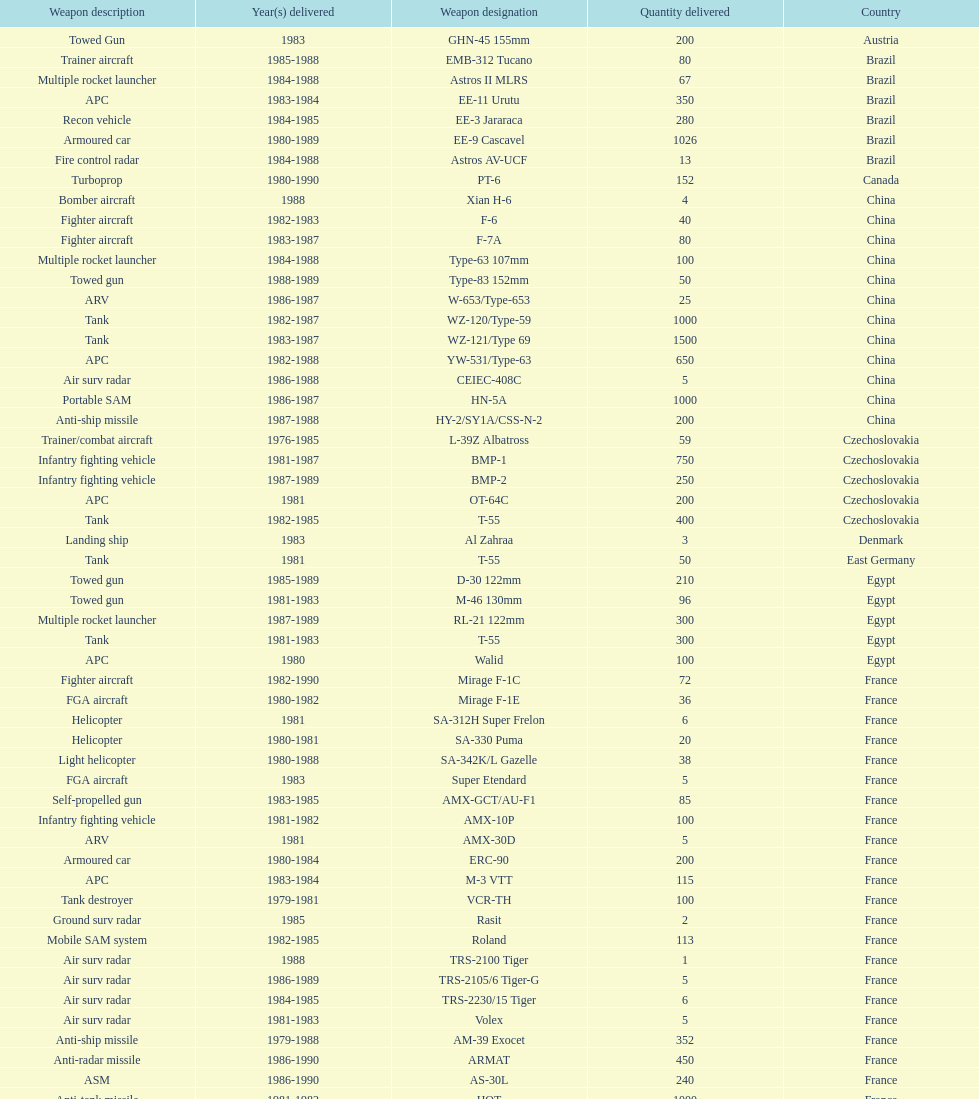Which country had the largest number of towed guns delivered? Soviet Union. 